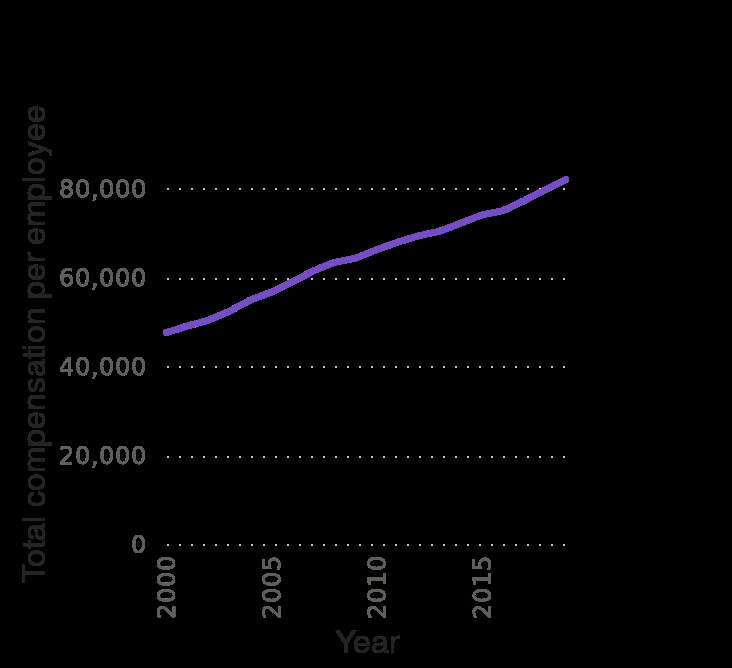<image>
What is the range of years represented on the x-axis of the line diagram?  The range of years on the x-axis is from 2000 to 2015. 